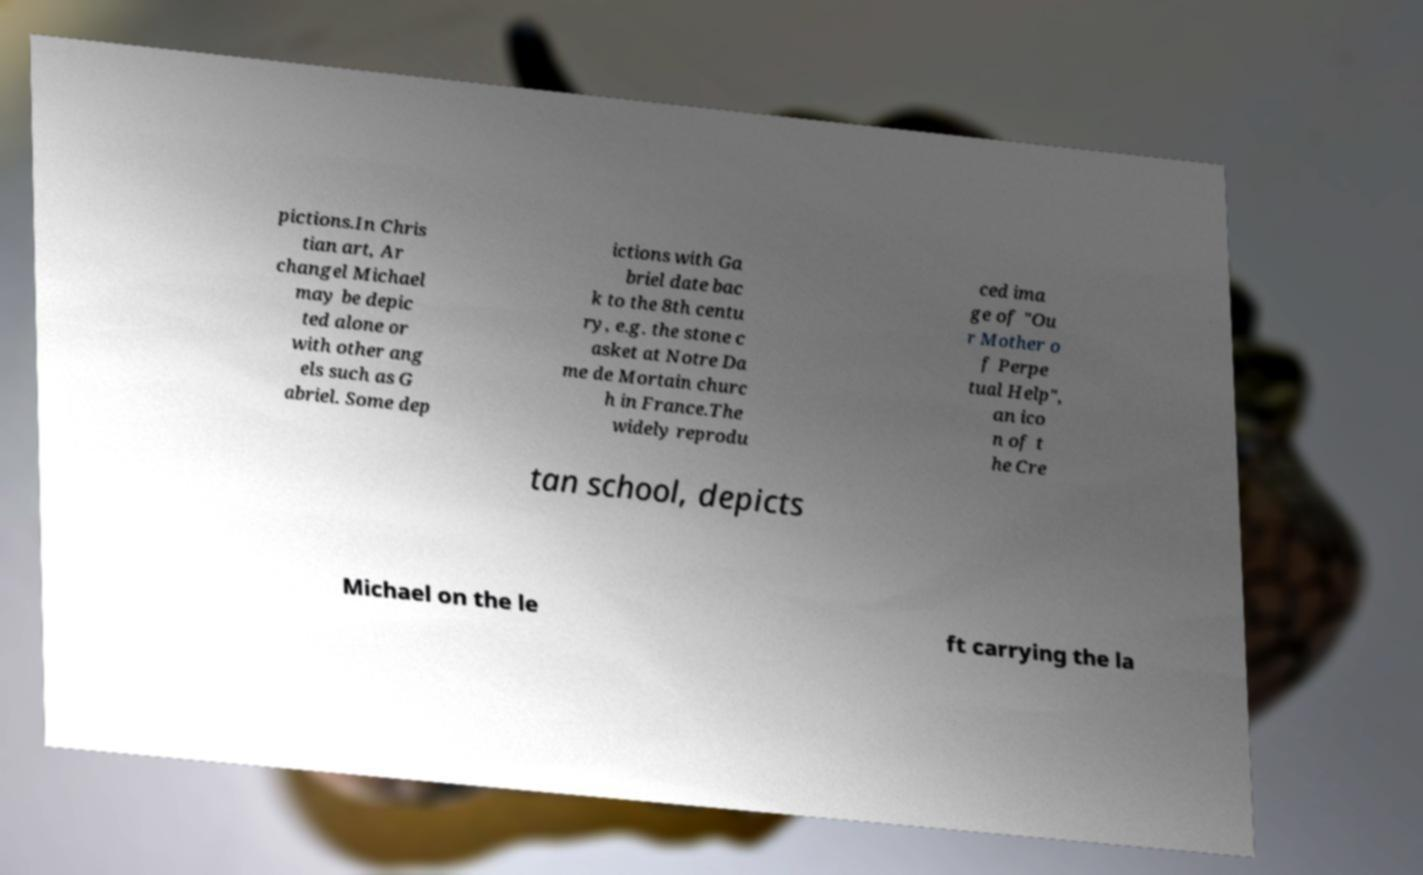I need the written content from this picture converted into text. Can you do that? pictions.In Chris tian art, Ar changel Michael may be depic ted alone or with other ang els such as G abriel. Some dep ictions with Ga briel date bac k to the 8th centu ry, e.g. the stone c asket at Notre Da me de Mortain churc h in France.The widely reprodu ced ima ge of "Ou r Mother o f Perpe tual Help", an ico n of t he Cre tan school, depicts Michael on the le ft carrying the la 